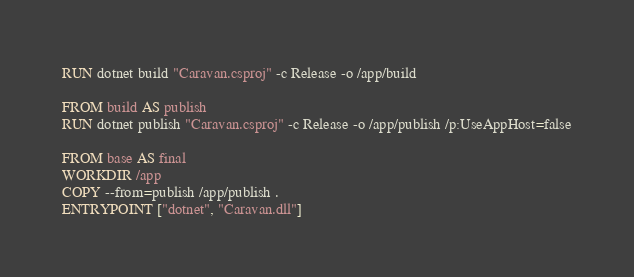Convert code to text. <code><loc_0><loc_0><loc_500><loc_500><_Dockerfile_>RUN dotnet build "Caravan.csproj" -c Release -o /app/build

FROM build AS publish
RUN dotnet publish "Caravan.csproj" -c Release -o /app/publish /p:UseAppHost=false

FROM base AS final
WORKDIR /app
COPY --from=publish /app/publish .
ENTRYPOINT ["dotnet", "Caravan.dll"]
</code> 